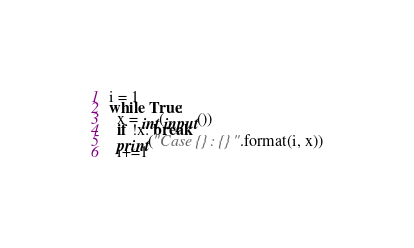<code> <loc_0><loc_0><loc_500><loc_500><_Python_>i = 1
while True:
  x = int(input())
  if !x: break
  print("Case {}: {}".format(i, x))
  i+=1
</code> 